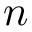Convert formula to latex. <formula><loc_0><loc_0><loc_500><loc_500>n</formula> 